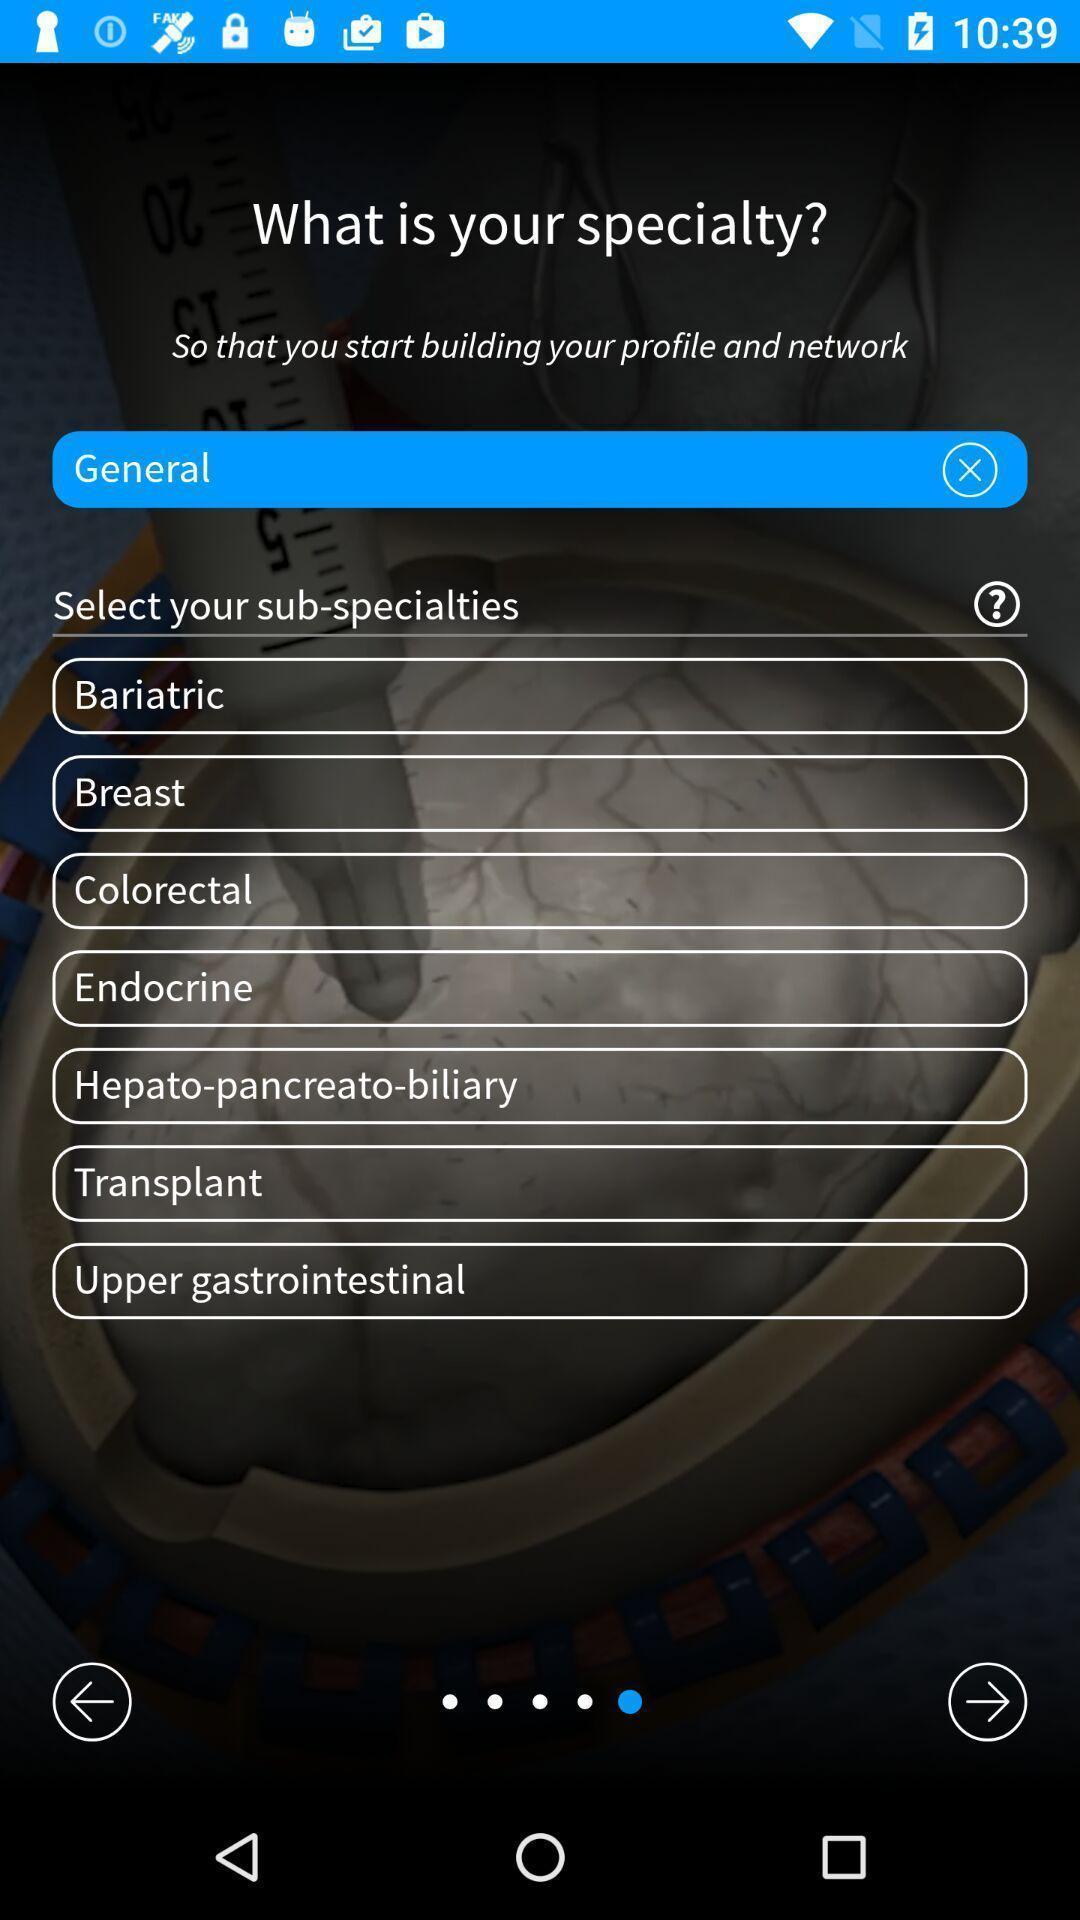Explain what's happening in this screen capture. Welcome page of surgeries management app with specialty select option. 